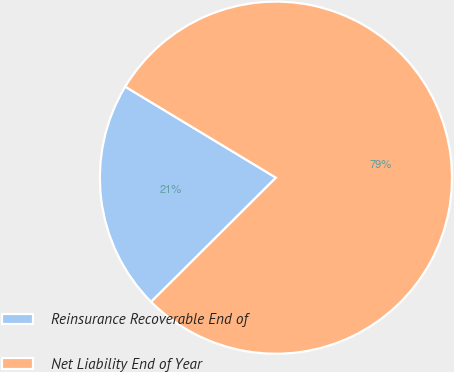Convert chart to OTSL. <chart><loc_0><loc_0><loc_500><loc_500><pie_chart><fcel>Reinsurance Recoverable End of<fcel>Net Liability End of Year<nl><fcel>21.11%<fcel>78.89%<nl></chart> 